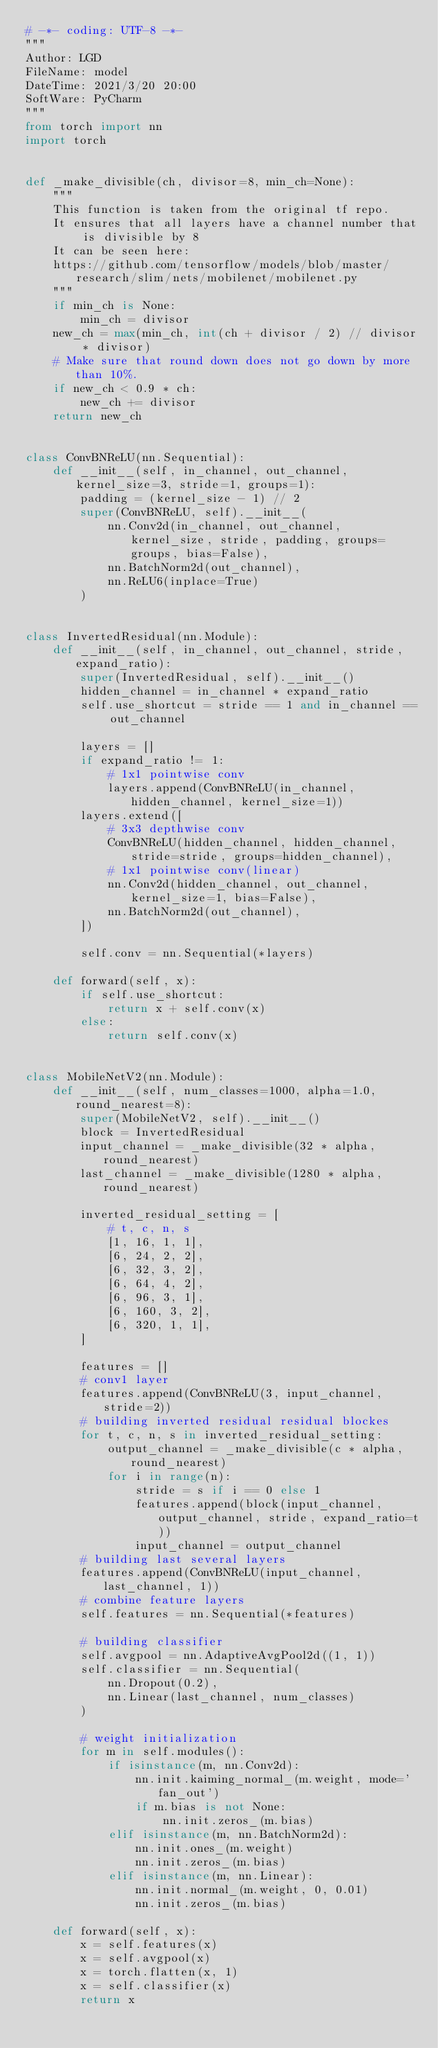Convert code to text. <code><loc_0><loc_0><loc_500><loc_500><_Python_># -*- coding: UTF-8 -*-
"""
Author: LGD
FileName: model
DateTime: 2021/3/20 20:00 
SoftWare: PyCharm
"""
from torch import nn
import torch


def _make_divisible(ch, divisor=8, min_ch=None):
    """
    This function is taken from the original tf repo.
    It ensures that all layers have a channel number that is divisible by 8
    It can be seen here:
    https://github.com/tensorflow/models/blob/master/research/slim/nets/mobilenet/mobilenet.py
    """
    if min_ch is None:
        min_ch = divisor
    new_ch = max(min_ch, int(ch + divisor / 2) // divisor * divisor)
    # Make sure that round down does not go down by more than 10%.
    if new_ch < 0.9 * ch:
        new_ch += divisor
    return new_ch


class ConvBNReLU(nn.Sequential):
    def __init__(self, in_channel, out_channel, kernel_size=3, stride=1, groups=1):
        padding = (kernel_size - 1) // 2
        super(ConvBNReLU, self).__init__(
            nn.Conv2d(in_channel, out_channel, kernel_size, stride, padding, groups=groups, bias=False),
            nn.BatchNorm2d(out_channel),
            nn.ReLU6(inplace=True)
        )


class InvertedResidual(nn.Module):
    def __init__(self, in_channel, out_channel, stride, expand_ratio):
        super(InvertedResidual, self).__init__()
        hidden_channel = in_channel * expand_ratio
        self.use_shortcut = stride == 1 and in_channel == out_channel

        layers = []
        if expand_ratio != 1:
            # 1x1 pointwise conv
            layers.append(ConvBNReLU(in_channel, hidden_channel, kernel_size=1))
        layers.extend([
            # 3x3 depthwise conv
            ConvBNReLU(hidden_channel, hidden_channel, stride=stride, groups=hidden_channel),
            # 1x1 pointwise conv(linear)
            nn.Conv2d(hidden_channel, out_channel, kernel_size=1, bias=False),
            nn.BatchNorm2d(out_channel),
        ])

        self.conv = nn.Sequential(*layers)

    def forward(self, x):
        if self.use_shortcut:
            return x + self.conv(x)
        else:
            return self.conv(x)


class MobileNetV2(nn.Module):
    def __init__(self, num_classes=1000, alpha=1.0, round_nearest=8):
        super(MobileNetV2, self).__init__()
        block = InvertedResidual
        input_channel = _make_divisible(32 * alpha, round_nearest)
        last_channel = _make_divisible(1280 * alpha, round_nearest)

        inverted_residual_setting = [
            # t, c, n, s
            [1, 16, 1, 1],
            [6, 24, 2, 2],
            [6, 32, 3, 2],
            [6, 64, 4, 2],
            [6, 96, 3, 1],
            [6, 160, 3, 2],
            [6, 320, 1, 1],
        ]

        features = []
        # conv1 layer
        features.append(ConvBNReLU(3, input_channel, stride=2))
        # building inverted residual residual blockes
        for t, c, n, s in inverted_residual_setting:
            output_channel = _make_divisible(c * alpha, round_nearest)
            for i in range(n):
                stride = s if i == 0 else 1
                features.append(block(input_channel, output_channel, stride, expand_ratio=t))
                input_channel = output_channel
        # building last several layers
        features.append(ConvBNReLU(input_channel, last_channel, 1))
        # combine feature layers
        self.features = nn.Sequential(*features)

        # building classifier
        self.avgpool = nn.AdaptiveAvgPool2d((1, 1))
        self.classifier = nn.Sequential(
            nn.Dropout(0.2),
            nn.Linear(last_channel, num_classes)
        )

        # weight initialization
        for m in self.modules():
            if isinstance(m, nn.Conv2d):
                nn.init.kaiming_normal_(m.weight, mode='fan_out')
                if m.bias is not None:
                    nn.init.zeros_(m.bias)
            elif isinstance(m, nn.BatchNorm2d):
                nn.init.ones_(m.weight)
                nn.init.zeros_(m.bias)
            elif isinstance(m, nn.Linear):
                nn.init.normal_(m.weight, 0, 0.01)
                nn.init.zeros_(m.bias)

    def forward(self, x):
        x = self.features(x)
        x = self.avgpool(x)
        x = torch.flatten(x, 1)
        x = self.classifier(x)
        return x
</code> 